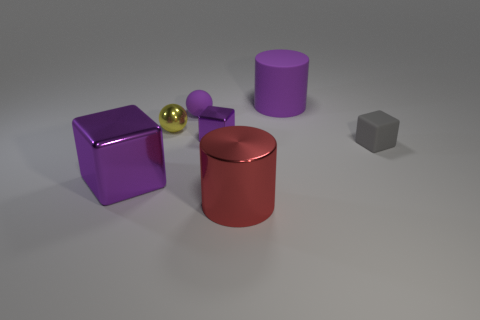There is a yellow thing; what shape is it?
Provide a short and direct response. Sphere. Are there the same number of red shiny cylinders that are in front of the yellow metal object and matte blocks?
Provide a succinct answer. Yes. Is the material of the large cylinder in front of the small metallic block the same as the small gray block?
Keep it short and to the point. No. Is the number of red cylinders behind the big red cylinder less than the number of big cyan matte cubes?
Your answer should be compact. No. What number of matte objects are green cylinders or purple cylinders?
Your answer should be compact. 1. Does the big metallic block have the same color as the tiny shiny block?
Offer a very short reply. Yes. Is there anything else that has the same color as the rubber sphere?
Your answer should be very brief. Yes. Is the shape of the large purple object in front of the tiny gray rubber object the same as the small matte thing in front of the tiny purple matte sphere?
Make the answer very short. Yes. What number of things are rubber things or cubes on the right side of the purple rubber cylinder?
Provide a succinct answer. 3. What number of other objects are there of the same size as the shiny cylinder?
Offer a terse response. 2. 